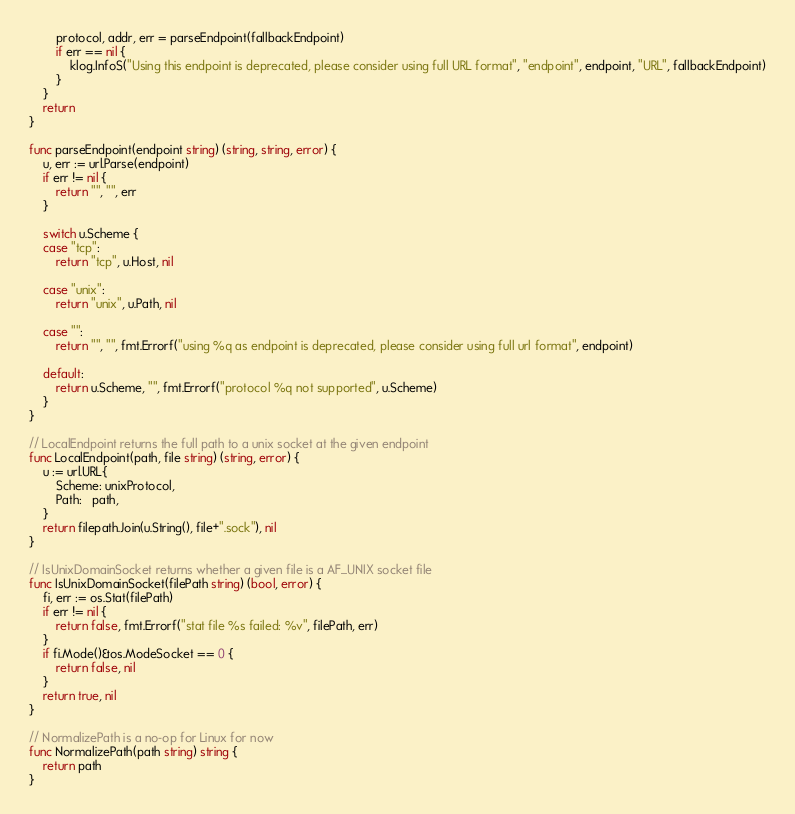Convert code to text. <code><loc_0><loc_0><loc_500><loc_500><_Go_>		protocol, addr, err = parseEndpoint(fallbackEndpoint)
		if err == nil {
			klog.InfoS("Using this endpoint is deprecated, please consider using full URL format", "endpoint", endpoint, "URL", fallbackEndpoint)
		}
	}
	return
}

func parseEndpoint(endpoint string) (string, string, error) {
	u, err := url.Parse(endpoint)
	if err != nil {
		return "", "", err
	}

	switch u.Scheme {
	case "tcp":
		return "tcp", u.Host, nil

	case "unix":
		return "unix", u.Path, nil

	case "":
		return "", "", fmt.Errorf("using %q as endpoint is deprecated, please consider using full url format", endpoint)

	default:
		return u.Scheme, "", fmt.Errorf("protocol %q not supported", u.Scheme)
	}
}

// LocalEndpoint returns the full path to a unix socket at the given endpoint
func LocalEndpoint(path, file string) (string, error) {
	u := url.URL{
		Scheme: unixProtocol,
		Path:   path,
	}
	return filepath.Join(u.String(), file+".sock"), nil
}

// IsUnixDomainSocket returns whether a given file is a AF_UNIX socket file
func IsUnixDomainSocket(filePath string) (bool, error) {
	fi, err := os.Stat(filePath)
	if err != nil {
		return false, fmt.Errorf("stat file %s failed: %v", filePath, err)
	}
	if fi.Mode()&os.ModeSocket == 0 {
		return false, nil
	}
	return true, nil
}

// NormalizePath is a no-op for Linux for now
func NormalizePath(path string) string {
	return path
}
</code> 